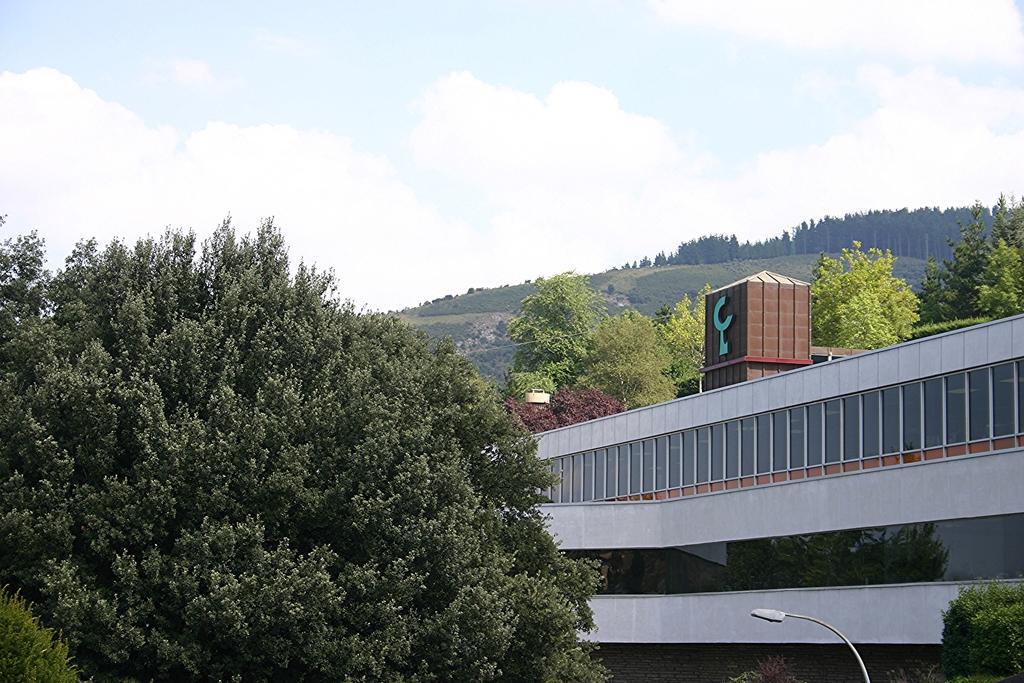Please provide a concise description of this image. In this image I can see number of trees and on the right side of this image I can see a building and a street light. In the background I can see a ropeway trolley, clouds and the sky. 